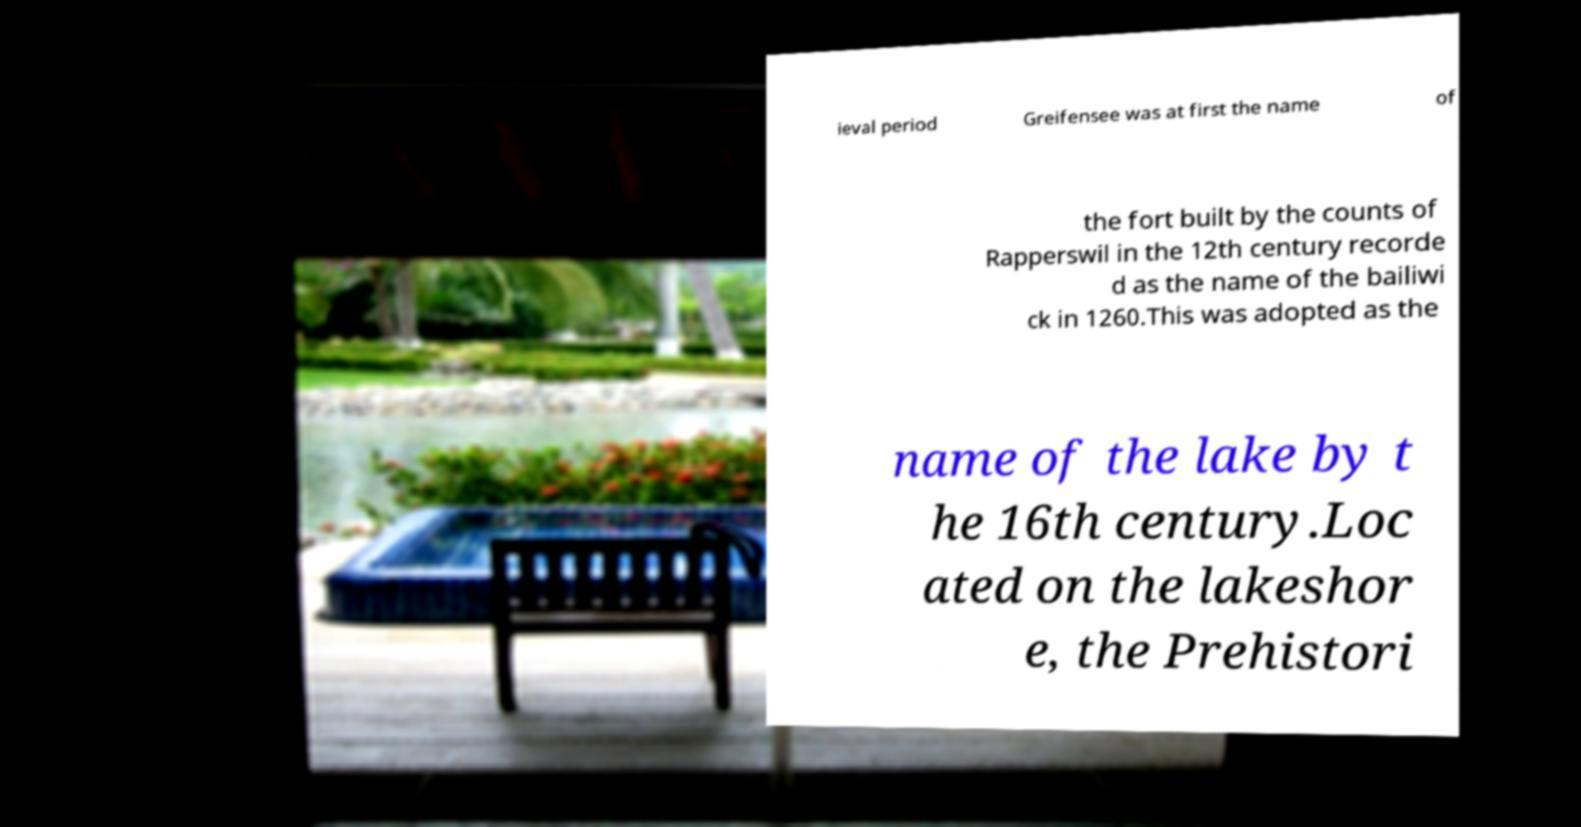I need the written content from this picture converted into text. Can you do that? ieval period Greifensee was at first the name of the fort built by the counts of Rapperswil in the 12th century recorde d as the name of the bailiwi ck in 1260.This was adopted as the name of the lake by t he 16th century.Loc ated on the lakeshor e, the Prehistori 